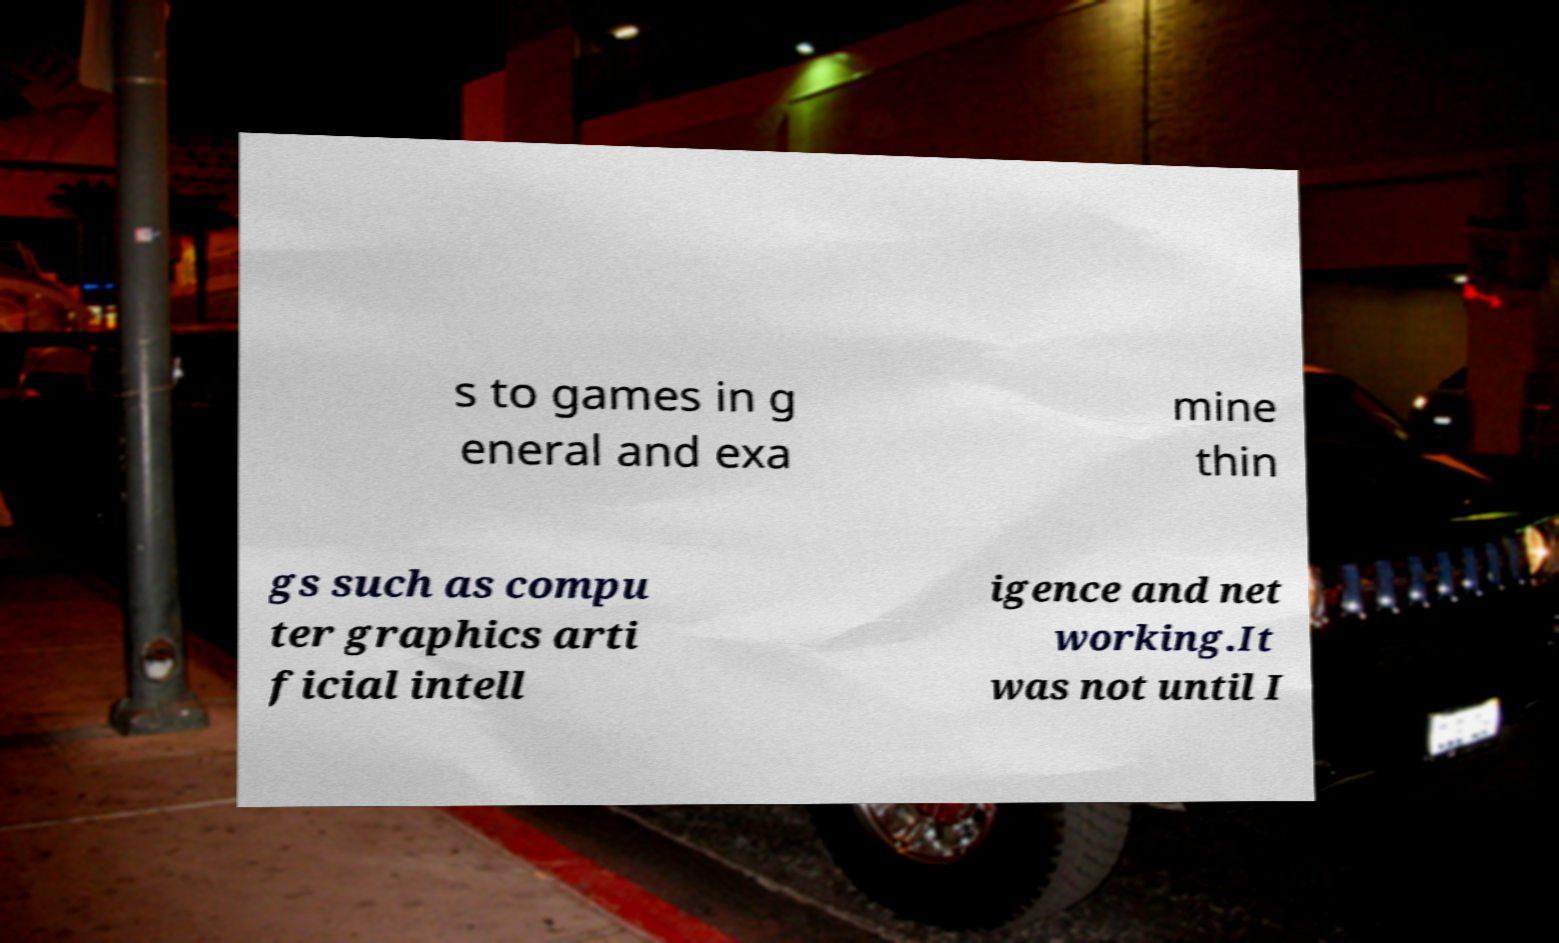Please read and relay the text visible in this image. What does it say? s to games in g eneral and exa mine thin gs such as compu ter graphics arti ficial intell igence and net working.It was not until I 